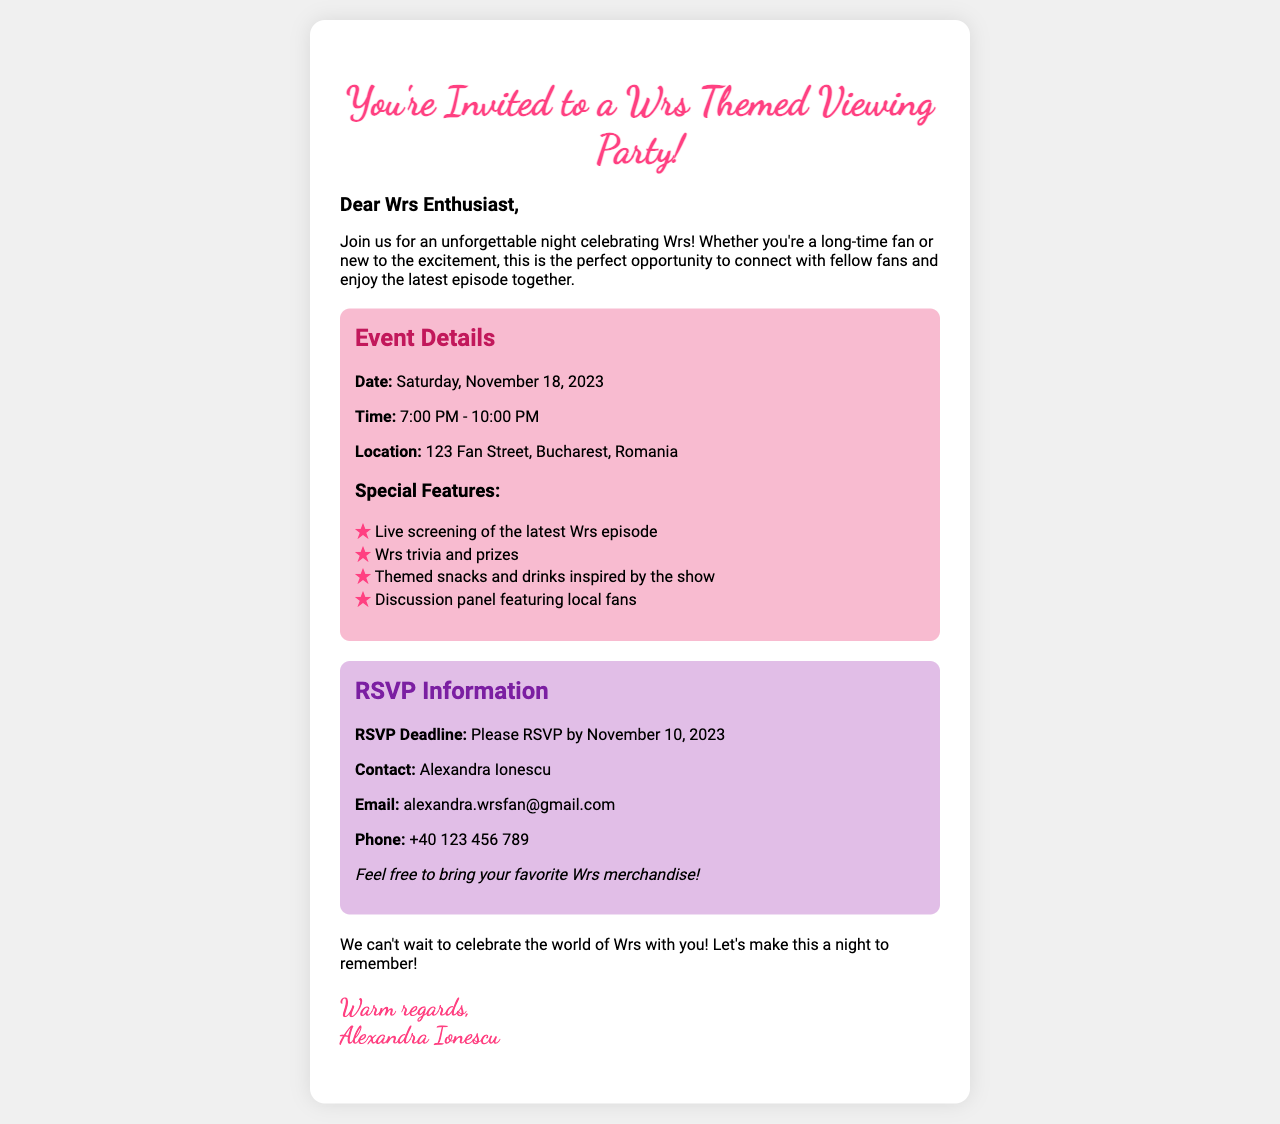What is the date of the viewing party? The date is mentioned clearly in the event details section as Saturday, November 18, 2023.
Answer: Saturday, November 18, 2023 What time does the viewing party start? The starting time is indicated alongside the end time in the event details section.
Answer: 7:00 PM Where is the event located? The location is specified in the event details, providing a specific address.
Answer: 123 Fan Street, Bucharest, Romania Who should I contact for RSVP? Contact information is given in the RSVP section, naming the person to reach out to.
Answer: Alexandra Ionescu What is the RSVP deadline? The RSVP deadline is provided in the RSVP information section.
Answer: November 10, 2023 What activities will be featured at the party? Multiple activities are listed under "Special Features" in the event details, showcasing engagement opportunities.
Answer: Live screening, trivia, themed snacks, discussion panel How can I RSVP for the event? The document specifies the contact method to RSVP, including an email and phone number.
Answer: Email or phone What should I bring to the event? A suggestion is made in the RSVP section regarding merchandise that could enhance the experience.
Answer: Wrs merchandise 